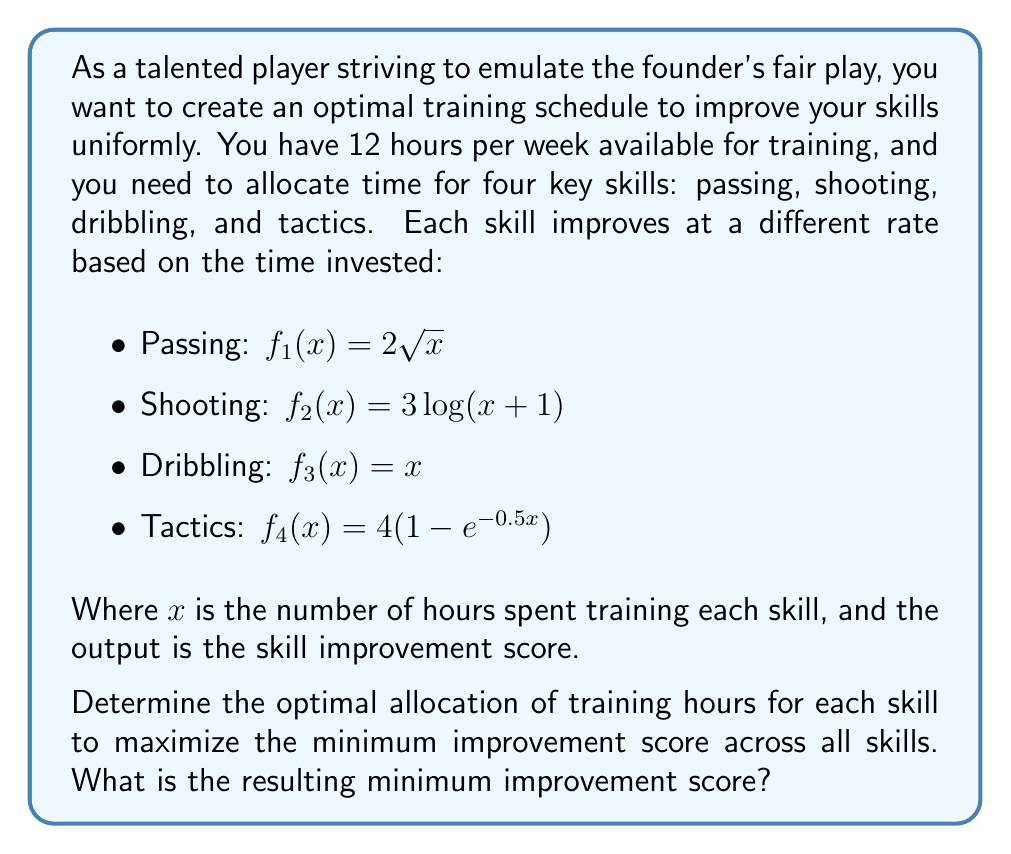Teach me how to tackle this problem. To solve this optimization problem, we need to use the concept of max-min optimization. We want to maximize the minimum improvement score across all skills, ensuring uniform improvement.

Let's approach this step-by-step:

1) First, we need to set up our constraint equation:
   $x_1 + x_2 + x_3 + x_4 = 12$, where $x_i$ represents the hours spent on each skill.

2) Our objective is to maximize $z$, where:
   $z = \min(f_1(x_1), f_2(x_2), f_3(x_3), f_4(x_4))$

3) For the optimal solution, all improvement scores should be equal:
   $f_1(x_1) = f_2(x_2) = f_3(x_3) = f_4(x_4) = z$

4) This gives us a system of equations:
   $2\sqrt{x_1} = z$
   $3\log(x_2+1) = z$
   $x_3 = z$
   $4(1-e^{-0.5x_4}) = z$

5) Solving these equations for $x_i$ in terms of $z$:
   $x_1 = (\frac{z}{2})^2$
   $x_2 = e^{\frac{z}{3}} - 1$
   $x_3 = z$
   $x_4 = -2\log(1-\frac{z}{4})$

6) Substituting these into our constraint equation:
   $(\frac{z}{2})^2 + e^{\frac{z}{3}} - 1 + z - 2\log(1-\frac{z}{4}) = 12$

7) This equation can be solved numerically. Using a numerical solver, we find:
   $z \approx 3.464$

8) Substituting this value back into our equations for $x_i$:
   $x_1 \approx 3.00$ hours
   $x_2 \approx 2.17$ hours
   $x_3 \approx 3.46$ hours
   $x_4 \approx 3.37$ hours

Therefore, the optimal allocation of training hours is approximately 3.00 hours for passing, 2.17 hours for shooting, 3.46 hours for dribbling, and 3.37 hours for tactics. This results in a minimum improvement score of approximately 3.464 across all skills.
Answer: The optimal allocation of training hours is approximately:
Passing: 3.00 hours
Shooting: 2.17 hours
Dribbling: 3.46 hours
Tactics: 3.37 hours

The resulting minimum improvement score is approximately 3.464. 